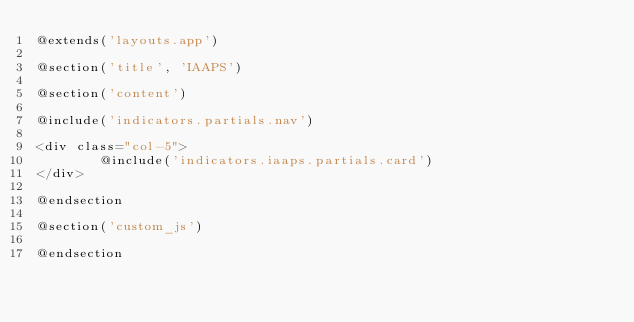<code> <loc_0><loc_0><loc_500><loc_500><_PHP_>@extends('layouts.app')

@section('title', 'IAAPS')

@section('content')

@include('indicators.partials.nav')

<div class="col-5">
        @include('indicators.iaaps.partials.card')
</div>

@endsection

@section('custom_js')

@endsection
</code> 